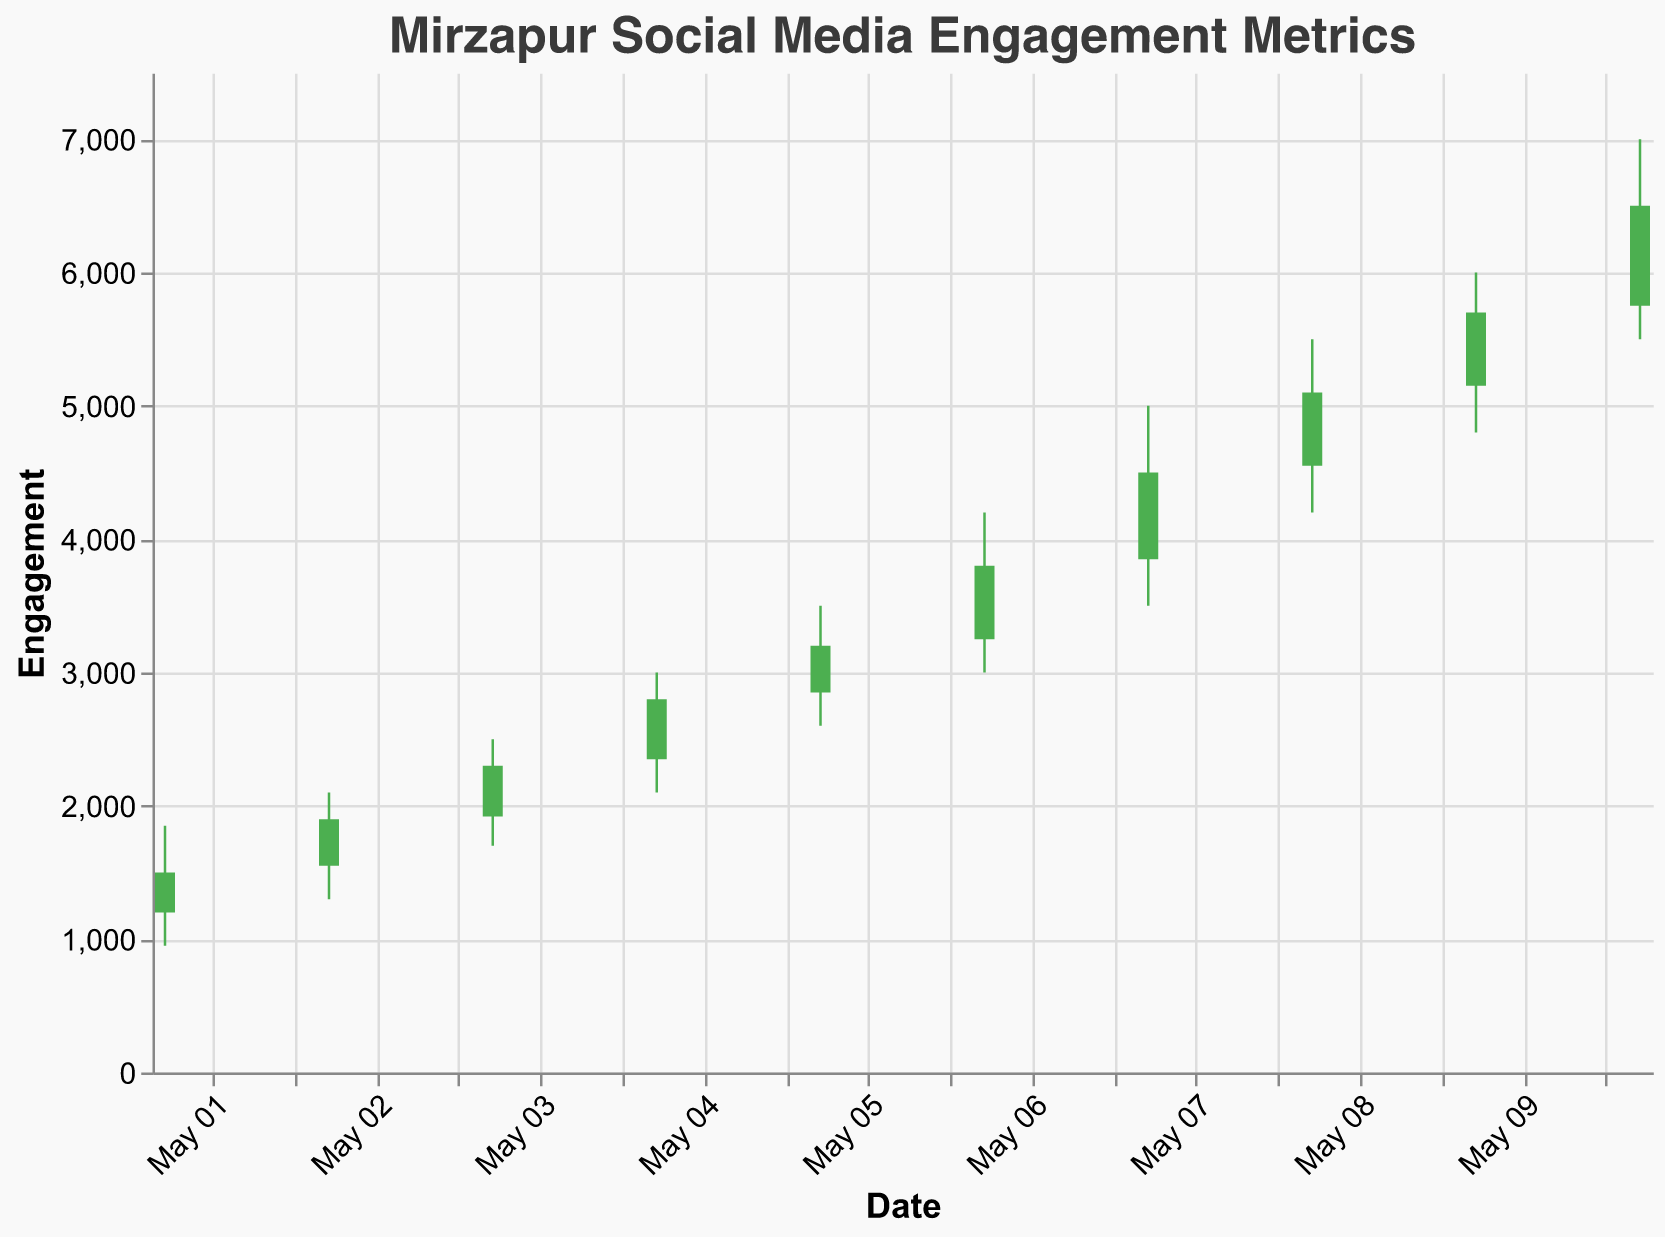Which day shows the lowest engagement? By looking for the lowest value in the "Low" column, the minimum engagement was on May 1st with an engagement of 950.
Answer: May 1 What is the trend of the closing engagement values over the ten days? The "Close" values start at 1500 on May 1st and end at 6500 on May 10th, showing a steady upward trend.
Answer: Upward trend Which day experienced the highest peak engagement? Examining the "High" column, the highest peak engagement value is 7000 on May 10th.
Answer: May 10 How does the opening value on May 5 compare to the closing value on May 5? The opening value on May 5 is 2850, and the closing value is 3200, indicating the closing value is higher than the opening value.
Answer: Closing value is higher Which date had the smallest range between low and high engagement values? The range is calculated as High - Low for each date. The smallest range is on May 1st (1850 - 950 = 900).
Answer: May 1 On which date did the engagement close at the highest value? Referring to the "Close" column, the highest closing value is 6500 on May 10th.
Answer: May 10 Which dates have a closing value higher than their opening value? Comparing the Close and Open values, the dates where the closing value is higher are: May 1, May 2, May 3, May 4, May 5, May 6, May 7, May 8, May 9, May 10.
Answer: All dates What is the average closing engagement from May 1 to May 10? Summing up the Close values: (1500 + 1900 + 2300 + 2800 + 3200 + 3800 + 4500 + 5100 + 5700 + 6500) = 37300, and dividing by the number of days which is 10: 37300/10 = 3730
Answer: 3730 Between May 6 and May 10, which day had the highest low value? Observing the "Low" column from May 6 to May 10, the highest low value is 5500 on May 10.
Answer: May 10 Did any day experience a drop in engagement from open to close? By comparing Open and Close values each day, there is no day where the close value is lower than the open value, hence no drops were experienced.
Answer: No 